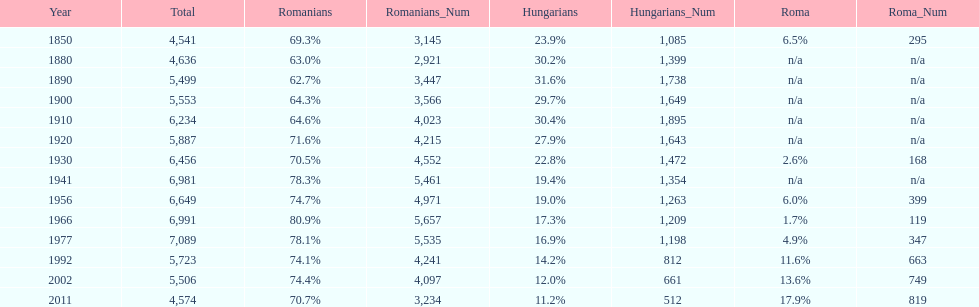Which year is previous to the year that had 74.1% in romanian population? 1977. 